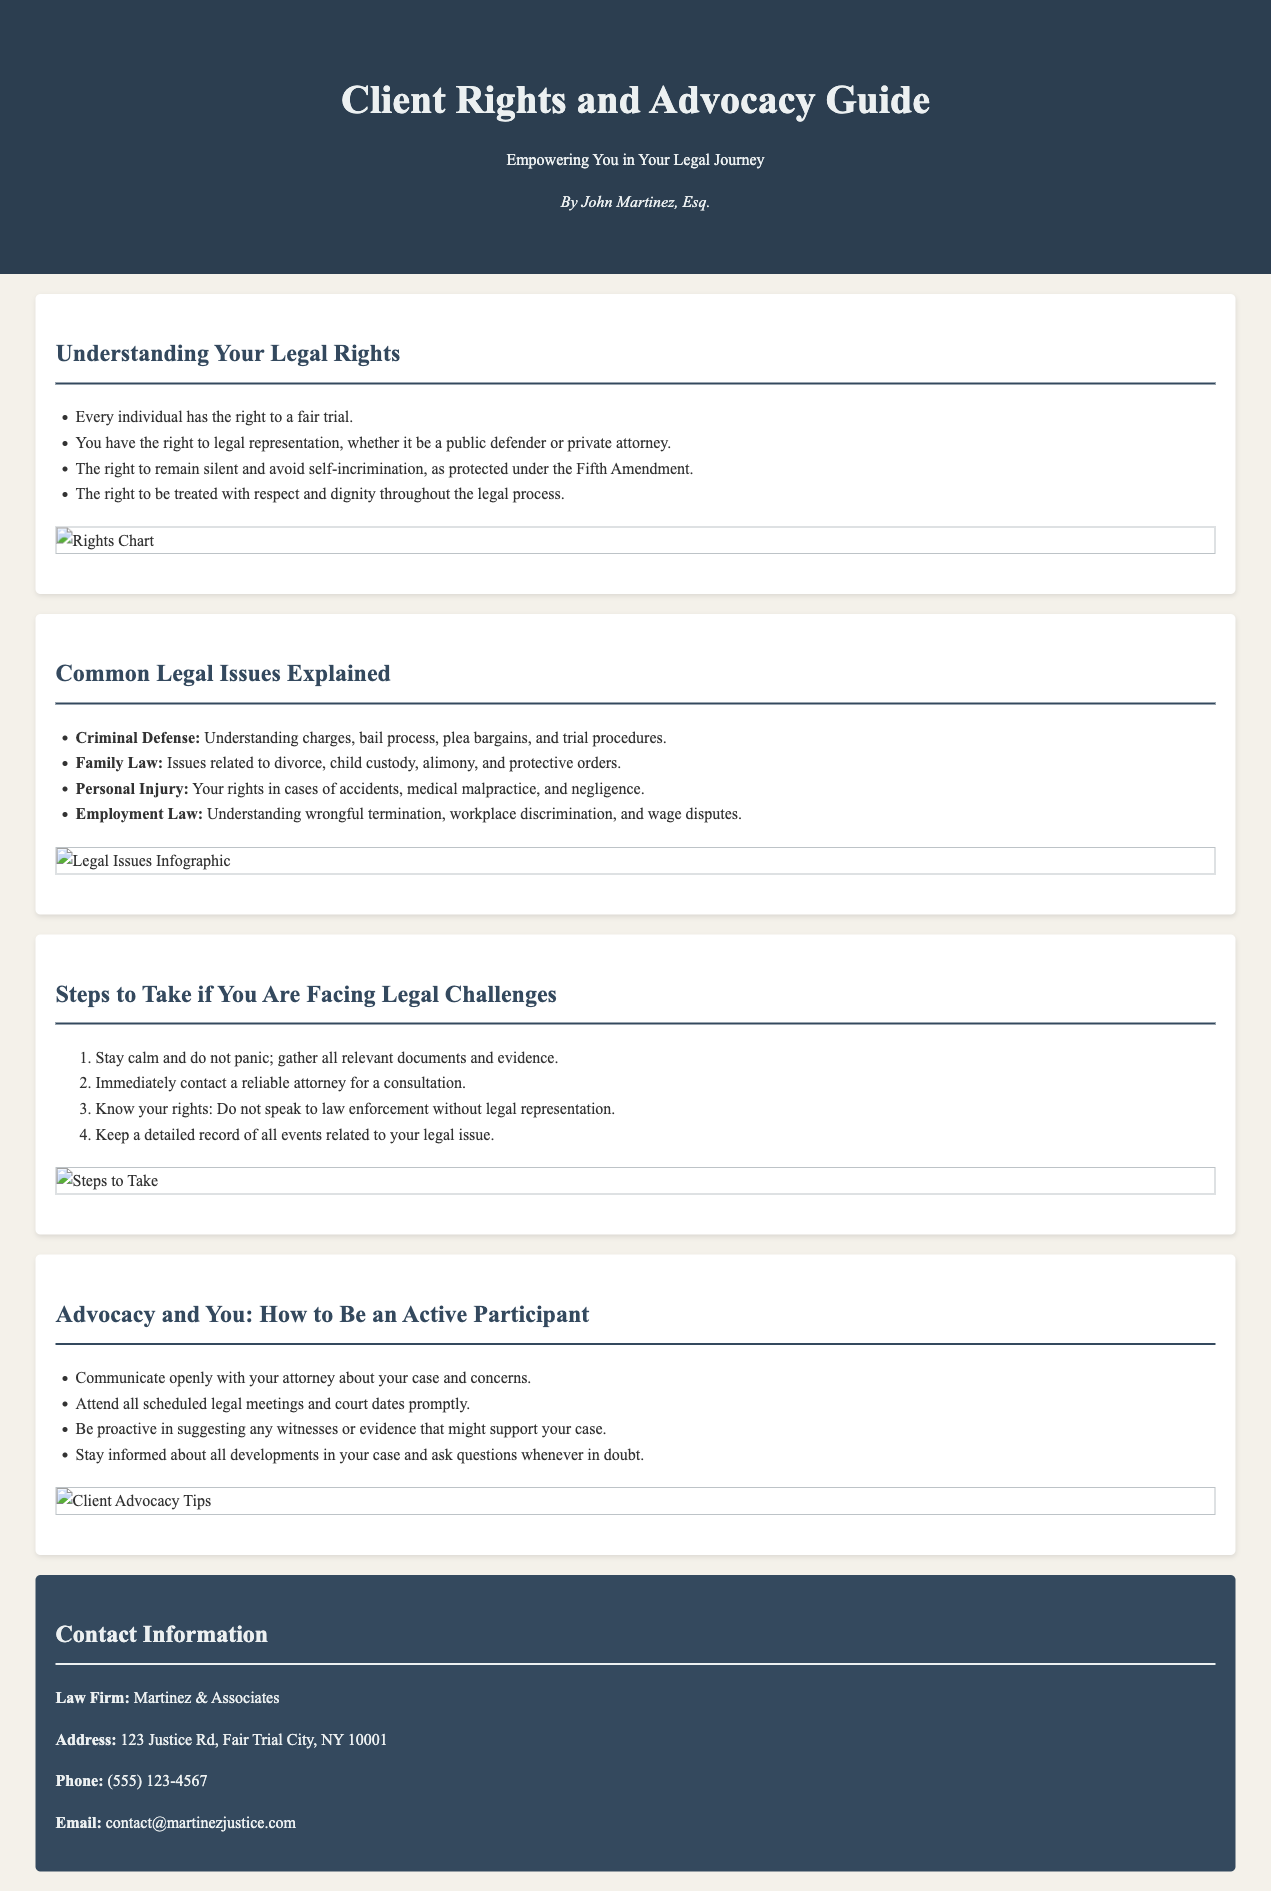What is the title of the guide? The title of the guide is prominently displayed at the top of the document.
Answer: Client Rights and Advocacy Guide Who is the author of the guide? The author's name is stated under the title in the header section of the document.
Answer: John Martinez, Esq What are the two rights mentioned under "Understanding Your Legal Rights"? The document lists specific rights in this section, highlighting important legal protections.
Answer: Fair trial, legal representation What is one common legal issue mentioned in the pamphlet? The document includes a list of various legal issues, indicating areas where clients may need guidance.
Answer: Criminal Defense What is the first step to take if facing legal challenges? The guide provides a numerical list of steps to follow during legal challenges, starting with an important action.
Answer: Stay calm How many legal issues are explained in the pamphlet? The document outlines several legal issues and can be counted from the provided list.
Answer: Four What type of law encompasses issues related to divorce? This question pertains to the designated category in the legal issues section, addressing family matters.
Answer: Family Law What should you do before speaking to law enforcement? The document advises on a critical step to take that protects the rights of clients in legal situations.
Answer: Know your rights What is the contact email for the law firm? The contact information section includes various ways to reach out to the law firm, including their email.
Answer: contact@martinezjustice.com 